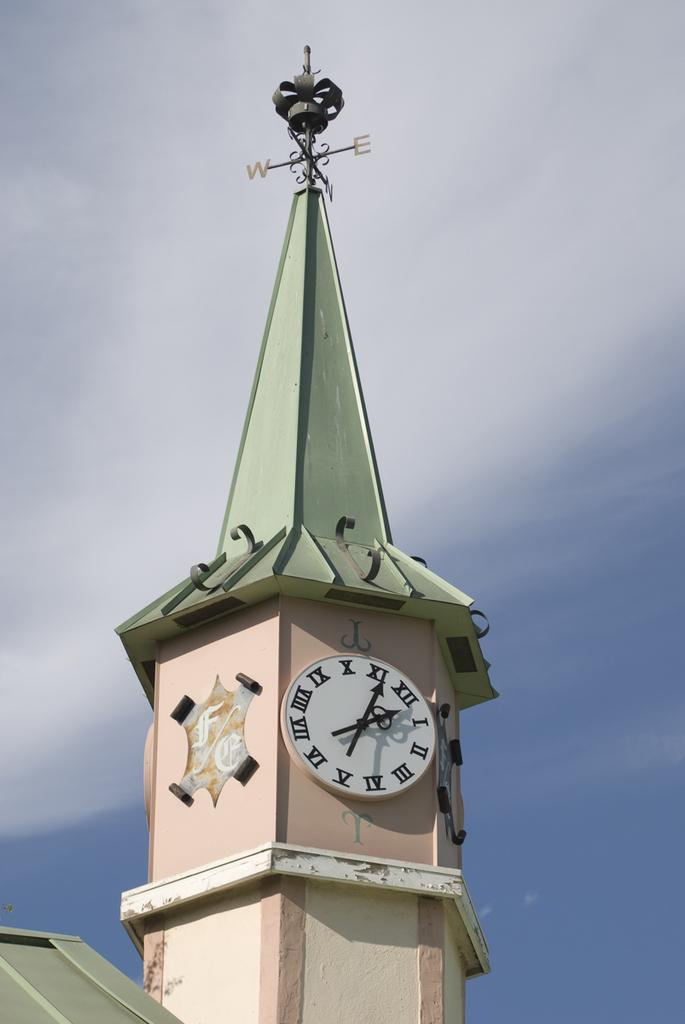<image>
Offer a succinct explanation of the picture presented. Building with a green roof and a clock with the hands on the 11 and 12. 